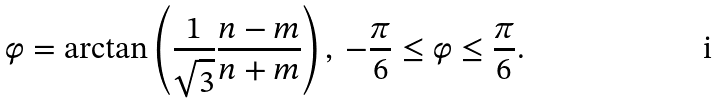Convert formula to latex. <formula><loc_0><loc_0><loc_500><loc_500>\varphi = \arctan \left ( \frac { 1 } { \sqrt { 3 } } \frac { n - m } { n + m } \right ) , \ - \frac { \pi } { 6 } \leq \varphi \leq \frac { \pi } { 6 } .</formula> 